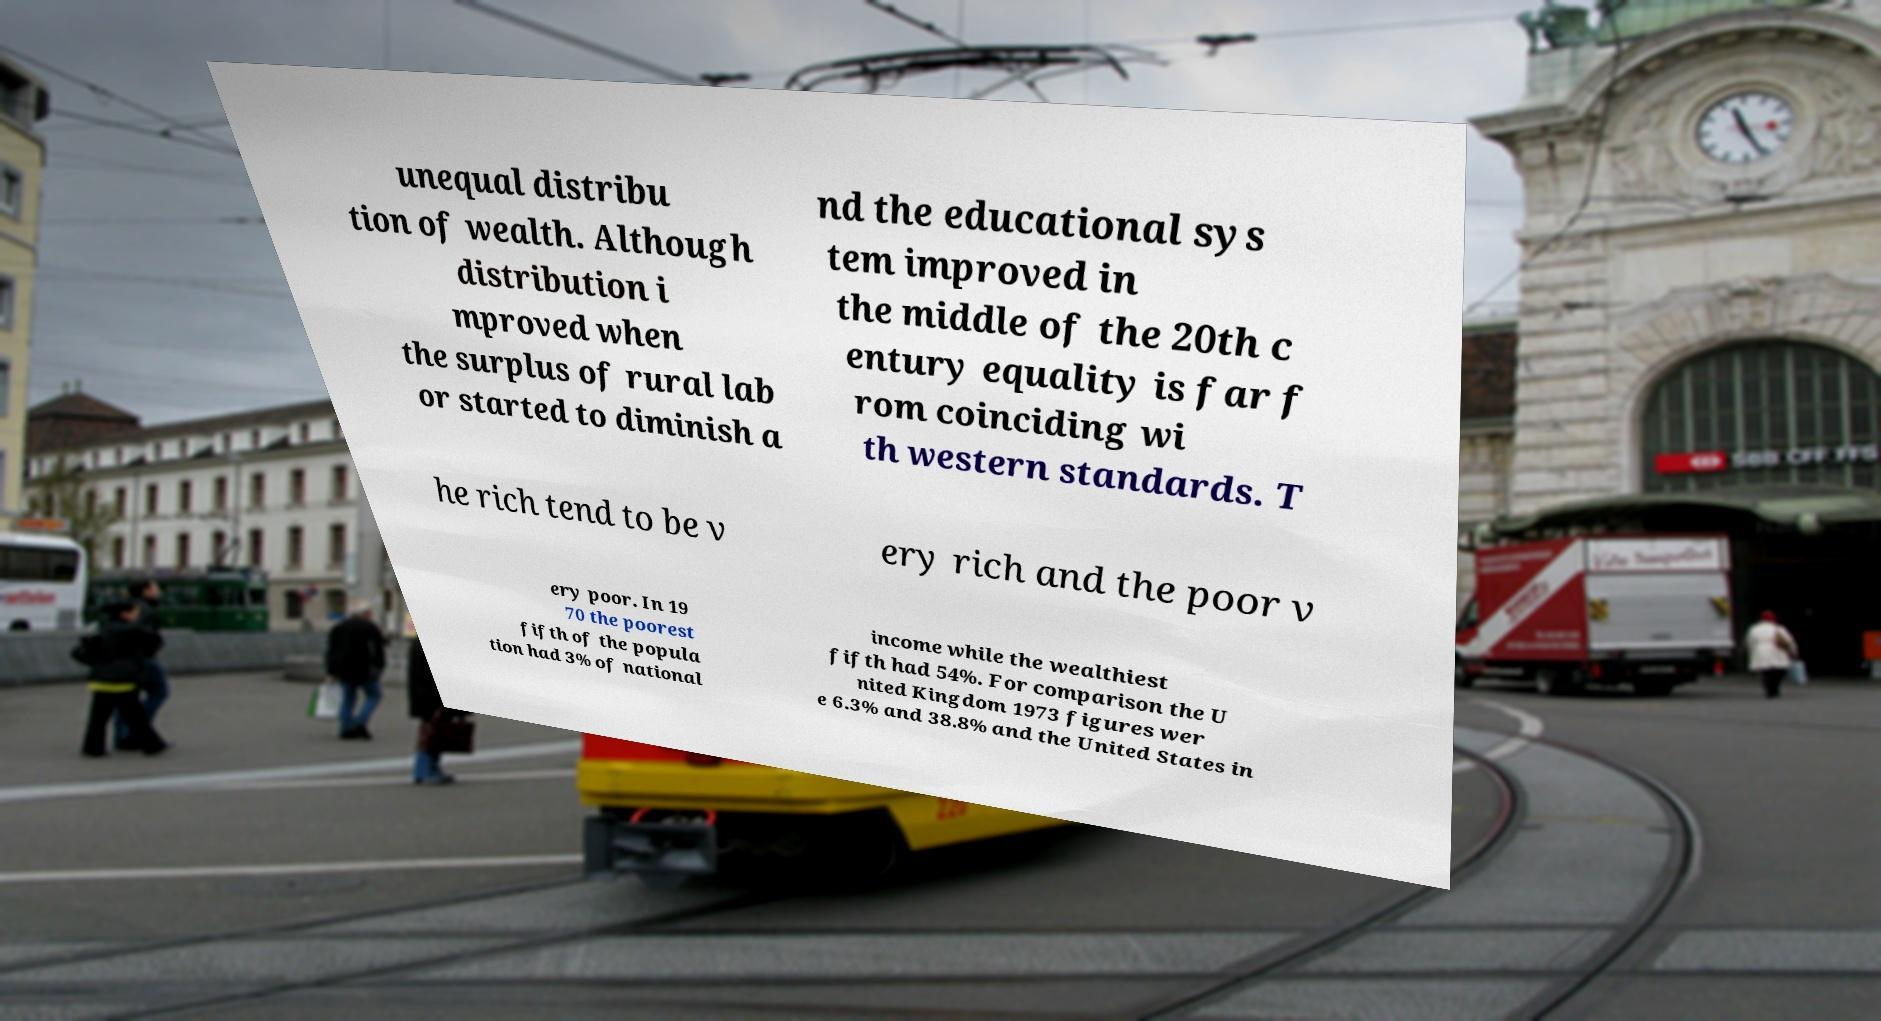Can you read and provide the text displayed in the image?This photo seems to have some interesting text. Can you extract and type it out for me? unequal distribu tion of wealth. Although distribution i mproved when the surplus of rural lab or started to diminish a nd the educational sys tem improved in the middle of the 20th c entury equality is far f rom coinciding wi th western standards. T he rich tend to be v ery rich and the poor v ery poor. In 19 70 the poorest fifth of the popula tion had 3% of national income while the wealthiest fifth had 54%. For comparison the U nited Kingdom 1973 figures wer e 6.3% and 38.8% and the United States in 